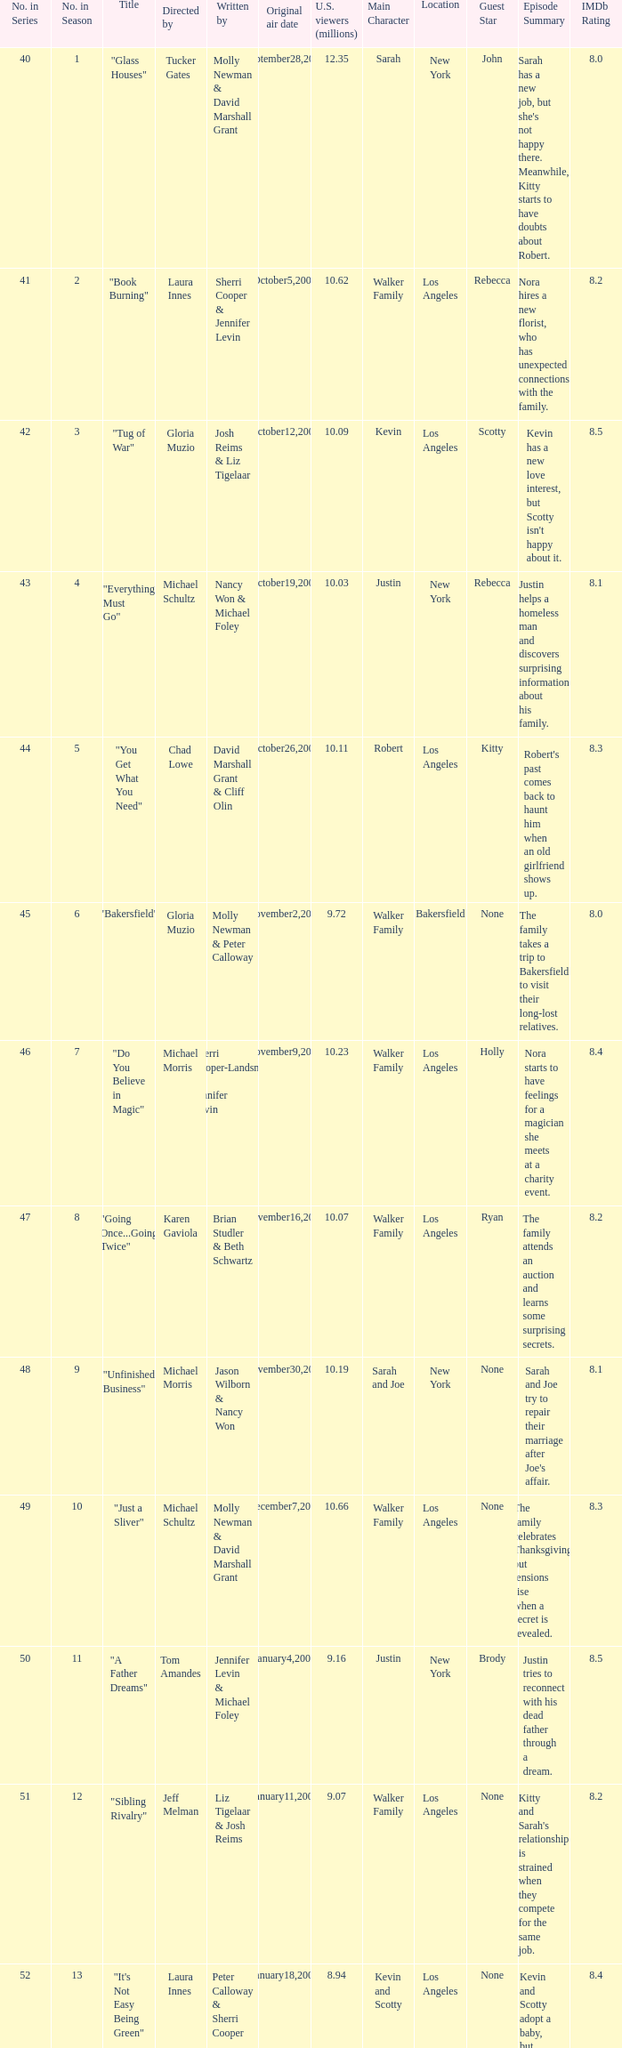When did the episode titled "Do you believe in magic" run for the first time? November9,2008. 